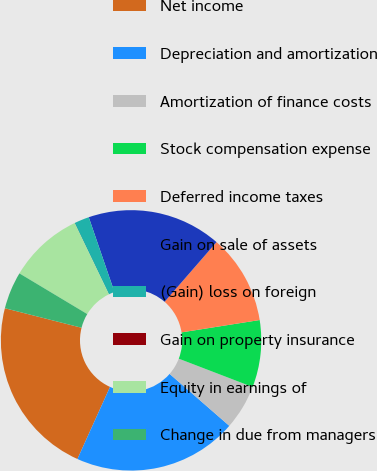<chart> <loc_0><loc_0><loc_500><loc_500><pie_chart><fcel>Net income<fcel>Depreciation and amortization<fcel>Amortization of finance costs<fcel>Stock compensation expense<fcel>Deferred income taxes<fcel>Gain on sale of assets<fcel>(Gain) loss on foreign<fcel>Gain on property insurance<fcel>Equity in earnings of<fcel>Change in due from managers<nl><fcel>22.21%<fcel>20.36%<fcel>5.56%<fcel>8.33%<fcel>11.11%<fcel>16.66%<fcel>1.86%<fcel>0.01%<fcel>9.26%<fcel>4.63%<nl></chart> 